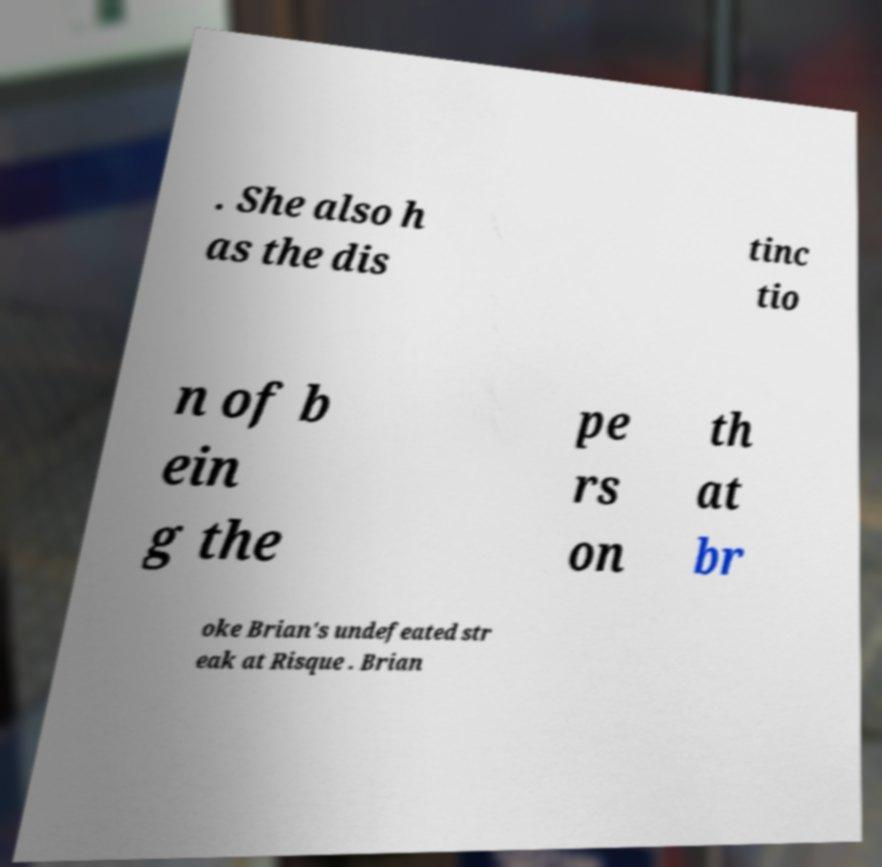Please identify and transcribe the text found in this image. . She also h as the dis tinc tio n of b ein g the pe rs on th at br oke Brian's undefeated str eak at Risque . Brian 